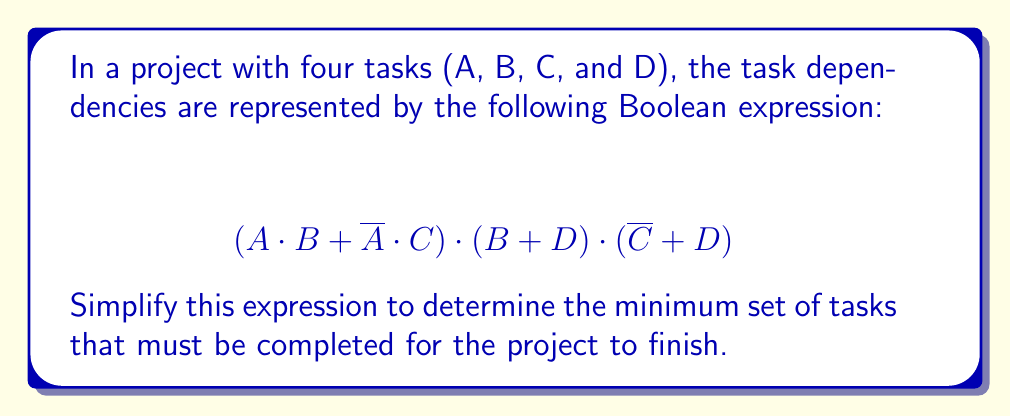What is the answer to this math problem? Let's simplify this Boolean expression step by step:

1) First, let's distribute $(B + D)$ over $(A \cdot B + \overline{A} \cdot C)$:
   $$(A \cdot B + \overline{A} \cdot C) \cdot (B + D) = (A \cdot B \cdot B + A \cdot B \cdot D + \overline{A} \cdot C \cdot B + \overline{A} \cdot C \cdot D)$$

2) Simplify $B \cdot B = B$:
   $$(A \cdot B + A \cdot B \cdot D + \overline{A} \cdot C \cdot B + \overline{A} \cdot C \cdot D)$$

3) Now, multiply this result by $(\overline{C} + D)$:
   $$(A \cdot B \cdot \overline{C} + A \cdot B \cdot D + A \cdot B \cdot D \cdot \overline{C} + A \cdot B \cdot D^2 + \overline{A} \cdot C \cdot B \cdot \overline{C} + \overline{A} \cdot C \cdot B \cdot D + \overline{A} \cdot C \cdot D \cdot \overline{C} + \overline{A} \cdot C \cdot D^2)$$

4) Simplify $D^2 = D$ and $C \cdot \overline{C} = 0$:
   $$(A \cdot B \cdot \overline{C} + A \cdot B \cdot D + A \cdot B \cdot D \cdot \overline{C} + A \cdot B \cdot D + \overline{A} \cdot C \cdot B \cdot D + \overline{A} \cdot C \cdot D)$$

5) Remove redundant terms:
   $$(A \cdot B \cdot \overline{C} + A \cdot B \cdot D + \overline{A} \cdot C \cdot B \cdot D + \overline{A} \cdot C \cdot D)$$

6) Factor out common terms:
   $$(A \cdot B \cdot (\overline{C} + D) + \overline{A} \cdot C \cdot D \cdot (B + 1))$$

7) Simplify $(B + 1) = 1$ (as $B + 1$ is always true in Boolean algebra):
   $$(A \cdot B \cdot (\overline{C} + D) + \overline{A} \cdot C \cdot D)$$

This simplified expression represents the minimum set of tasks that must be completed for the project to finish.
Answer: $(A \cdot B \cdot (\overline{C} + D) + \overline{A} \cdot C \cdot D)$ 